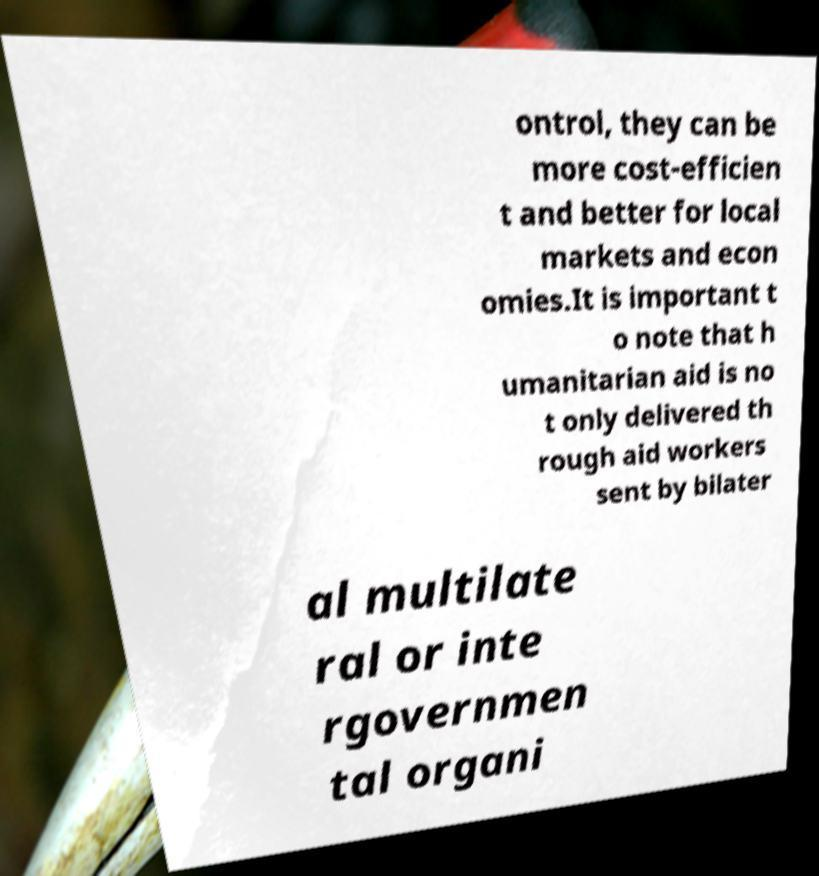Please read and relay the text visible in this image. What does it say? ontrol, they can be more cost-efficien t and better for local markets and econ omies.It is important t o note that h umanitarian aid is no t only delivered th rough aid workers sent by bilater al multilate ral or inte rgovernmen tal organi 